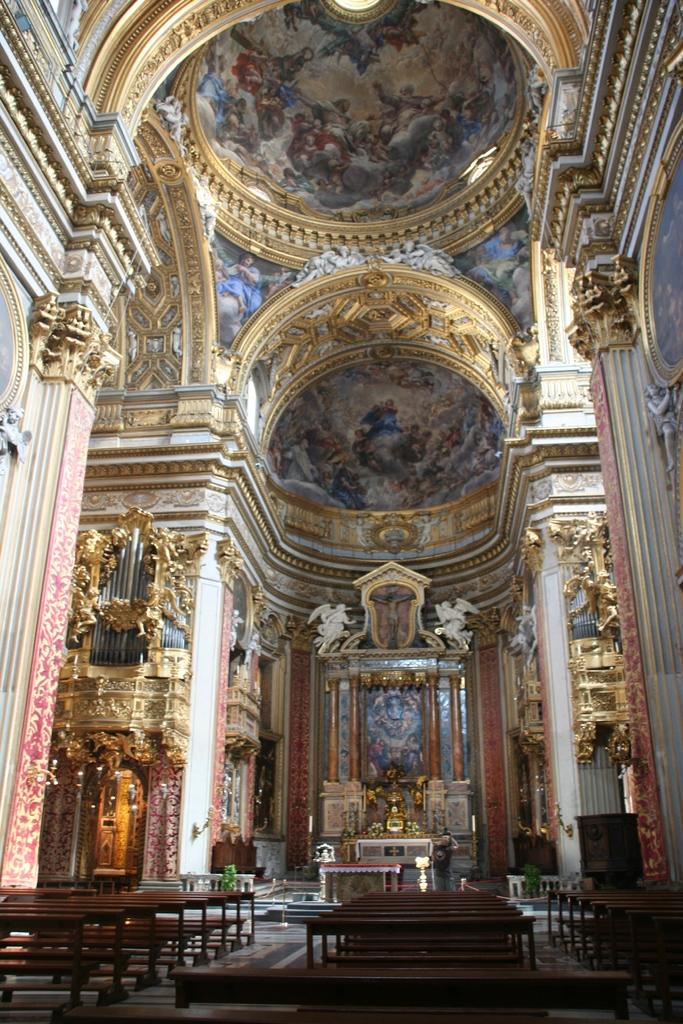What type of architecture is featured in the image? The image contains Pietro da Cortona architecture. What type of seating is available in the image? There are benches at the bottom side of the image. Where can the chickens be seen playing in the image? There are no chickens or any play-related activities depicted in the image. 